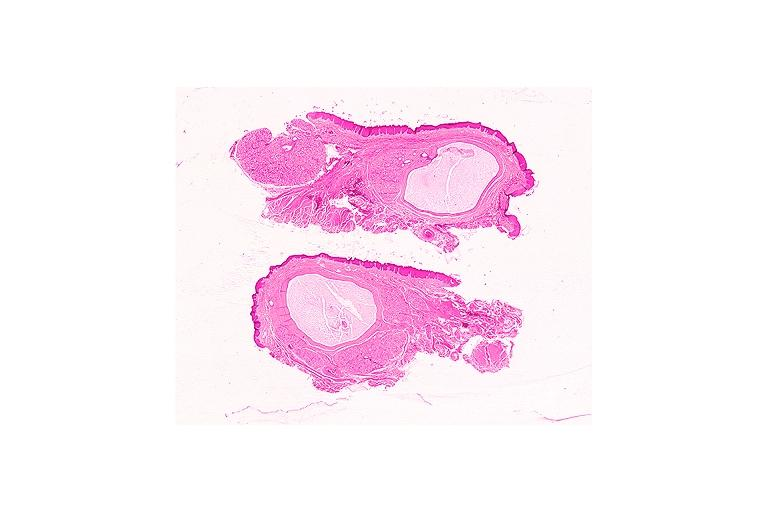where is this?
Answer the question using a single word or phrase. Oral 